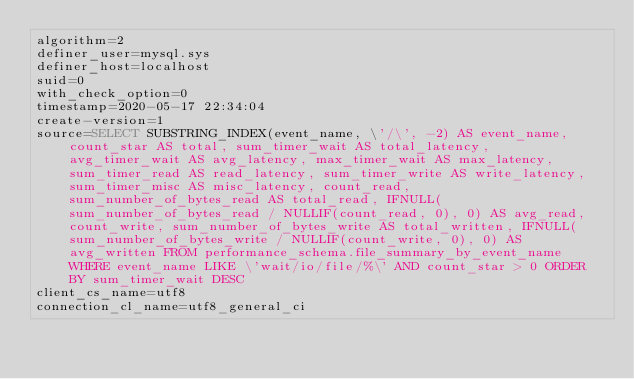<code> <loc_0><loc_0><loc_500><loc_500><_VisualBasic_>algorithm=2
definer_user=mysql.sys
definer_host=localhost
suid=0
with_check_option=0
timestamp=2020-05-17 22:34:04
create-version=1
source=SELECT SUBSTRING_INDEX(event_name, \'/\', -2) AS event_name, count_star AS total, sum_timer_wait AS total_latency, avg_timer_wait AS avg_latency, max_timer_wait AS max_latency, sum_timer_read AS read_latency, sum_timer_write AS write_latency, sum_timer_misc AS misc_latency, count_read, sum_number_of_bytes_read AS total_read, IFNULL(sum_number_of_bytes_read / NULLIF(count_read, 0), 0) AS avg_read, count_write, sum_number_of_bytes_write AS total_written, IFNULL(sum_number_of_bytes_write / NULLIF(count_write, 0), 0) AS avg_written FROM performance_schema.file_summary_by_event_name  WHERE event_name LIKE \'wait/io/file/%\' AND count_star > 0 ORDER BY sum_timer_wait DESC
client_cs_name=utf8
connection_cl_name=utf8_general_ci</code> 